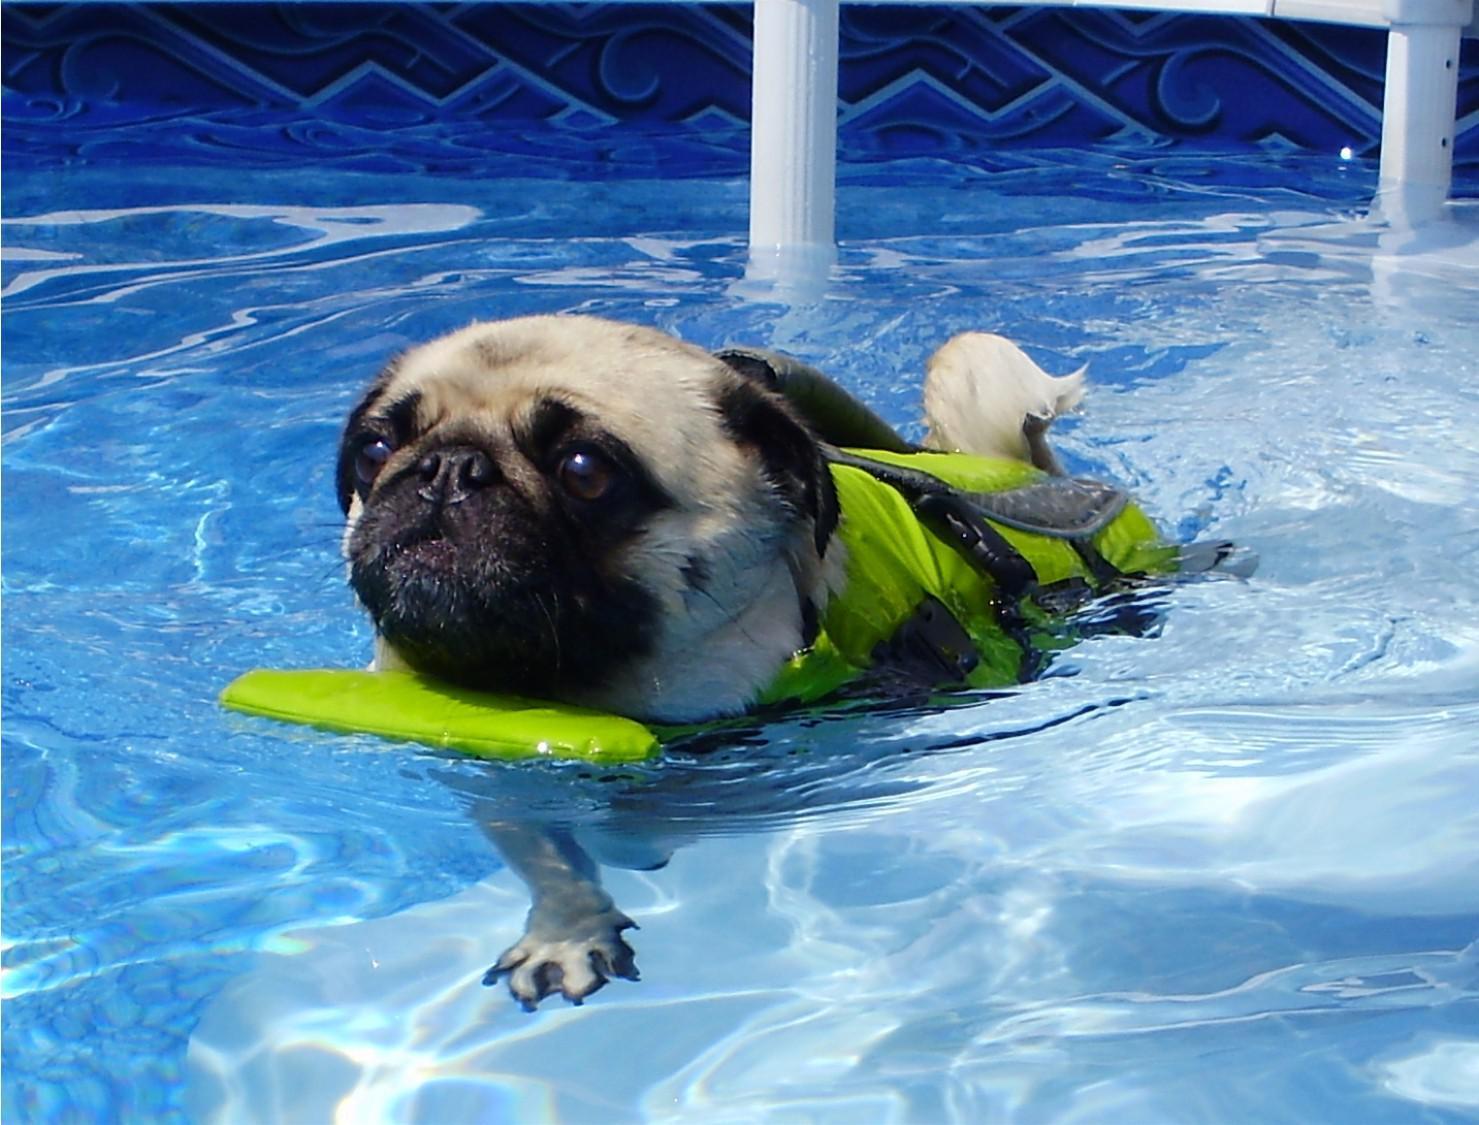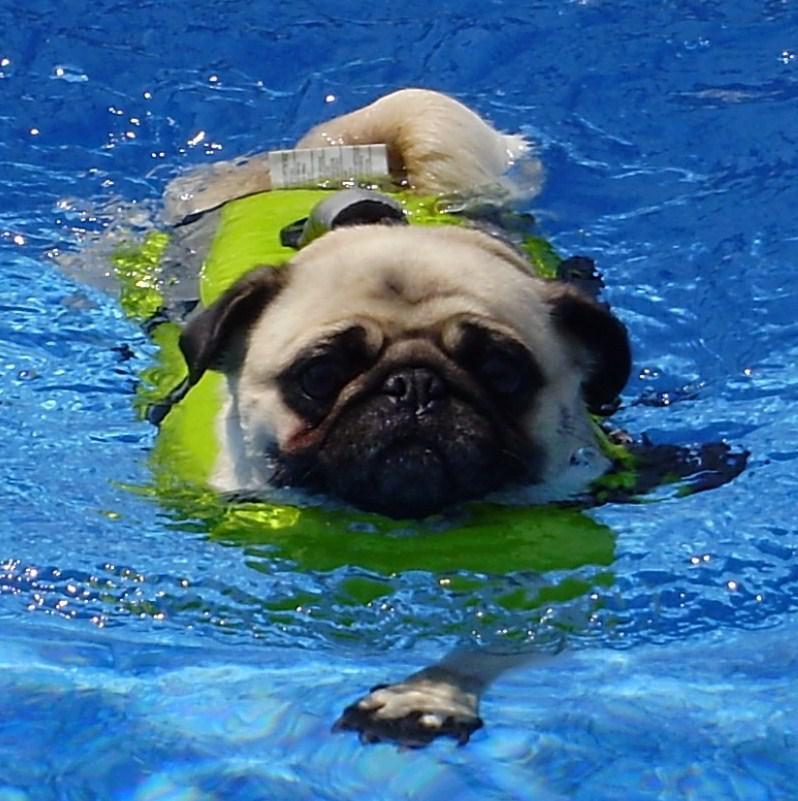The first image is the image on the left, the second image is the image on the right. Examine the images to the left and right. Is the description "The pug in the left image is wearing a swimming vest." accurate? Answer yes or no. Yes. The first image is the image on the left, the second image is the image on the right. Evaluate the accuracy of this statement regarding the images: "Only one pug is wearing a life vest.". Is it true? Answer yes or no. No. 